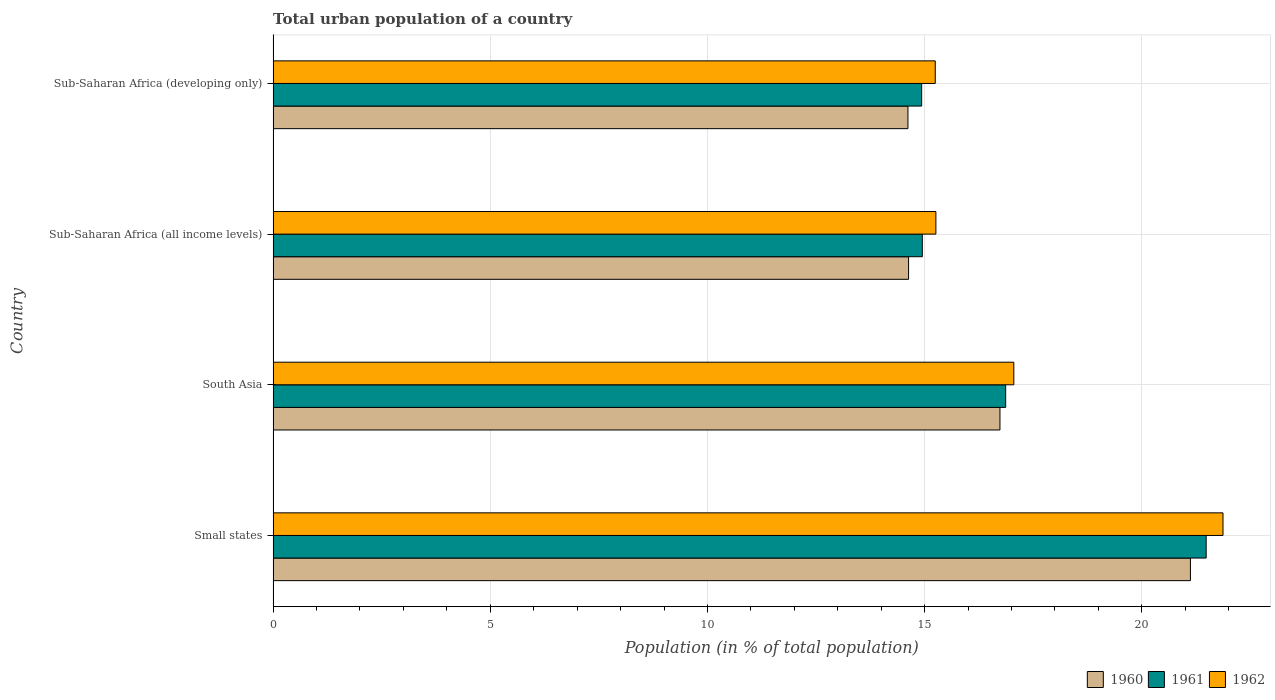How many groups of bars are there?
Offer a terse response. 4. Are the number of bars per tick equal to the number of legend labels?
Your response must be concise. Yes. Are the number of bars on each tick of the Y-axis equal?
Make the answer very short. Yes. How many bars are there on the 3rd tick from the bottom?
Provide a succinct answer. 3. What is the label of the 2nd group of bars from the top?
Offer a very short reply. Sub-Saharan Africa (all income levels). What is the urban population in 1962 in Small states?
Ensure brevity in your answer.  21.87. Across all countries, what is the maximum urban population in 1961?
Offer a very short reply. 21.48. Across all countries, what is the minimum urban population in 1962?
Give a very brief answer. 15.25. In which country was the urban population in 1962 maximum?
Your response must be concise. Small states. In which country was the urban population in 1962 minimum?
Offer a very short reply. Sub-Saharan Africa (developing only). What is the total urban population in 1962 in the graph?
Offer a terse response. 69.43. What is the difference between the urban population in 1960 in Small states and that in Sub-Saharan Africa (all income levels)?
Your answer should be very brief. 6.49. What is the difference between the urban population in 1961 in South Asia and the urban population in 1960 in Sub-Saharan Africa (all income levels)?
Provide a succinct answer. 2.24. What is the average urban population in 1960 per country?
Ensure brevity in your answer.  16.78. What is the difference between the urban population in 1960 and urban population in 1961 in Sub-Saharan Africa (developing only)?
Make the answer very short. -0.32. In how many countries, is the urban population in 1960 greater than 9 %?
Your response must be concise. 4. What is the ratio of the urban population in 1960 in Small states to that in Sub-Saharan Africa (developing only)?
Provide a succinct answer. 1.44. What is the difference between the highest and the second highest urban population in 1961?
Give a very brief answer. 4.62. What is the difference between the highest and the lowest urban population in 1962?
Your answer should be compact. 6.63. Is the sum of the urban population in 1961 in South Asia and Sub-Saharan Africa (developing only) greater than the maximum urban population in 1962 across all countries?
Offer a very short reply. Yes. What does the 2nd bar from the top in Small states represents?
Offer a terse response. 1961. What does the 1st bar from the bottom in Sub-Saharan Africa (all income levels) represents?
Ensure brevity in your answer.  1960. How many bars are there?
Offer a terse response. 12. Are all the bars in the graph horizontal?
Your response must be concise. Yes. What is the difference between two consecutive major ticks on the X-axis?
Provide a succinct answer. 5. Are the values on the major ticks of X-axis written in scientific E-notation?
Make the answer very short. No. Does the graph contain any zero values?
Give a very brief answer. No. Where does the legend appear in the graph?
Your answer should be compact. Bottom right. What is the title of the graph?
Offer a terse response. Total urban population of a country. Does "1976" appear as one of the legend labels in the graph?
Give a very brief answer. No. What is the label or title of the X-axis?
Your response must be concise. Population (in % of total population). What is the Population (in % of total population) of 1960 in Small states?
Provide a succinct answer. 21.12. What is the Population (in % of total population) of 1961 in Small states?
Ensure brevity in your answer.  21.48. What is the Population (in % of total population) of 1962 in Small states?
Offer a terse response. 21.87. What is the Population (in % of total population) of 1960 in South Asia?
Provide a short and direct response. 16.74. What is the Population (in % of total population) of 1961 in South Asia?
Provide a succinct answer. 16.87. What is the Population (in % of total population) in 1962 in South Asia?
Ensure brevity in your answer.  17.05. What is the Population (in % of total population) in 1960 in Sub-Saharan Africa (all income levels)?
Provide a short and direct response. 14.63. What is the Population (in % of total population) of 1961 in Sub-Saharan Africa (all income levels)?
Offer a terse response. 14.95. What is the Population (in % of total population) in 1962 in Sub-Saharan Africa (all income levels)?
Provide a short and direct response. 15.26. What is the Population (in % of total population) of 1960 in Sub-Saharan Africa (developing only)?
Give a very brief answer. 14.62. What is the Population (in % of total population) of 1961 in Sub-Saharan Africa (developing only)?
Offer a terse response. 14.93. What is the Population (in % of total population) in 1962 in Sub-Saharan Africa (developing only)?
Your response must be concise. 15.25. Across all countries, what is the maximum Population (in % of total population) in 1960?
Provide a short and direct response. 21.12. Across all countries, what is the maximum Population (in % of total population) of 1961?
Give a very brief answer. 21.48. Across all countries, what is the maximum Population (in % of total population) of 1962?
Give a very brief answer. 21.87. Across all countries, what is the minimum Population (in % of total population) in 1960?
Keep it short and to the point. 14.62. Across all countries, what is the minimum Population (in % of total population) in 1961?
Your response must be concise. 14.93. Across all countries, what is the minimum Population (in % of total population) of 1962?
Give a very brief answer. 15.25. What is the total Population (in % of total population) in 1960 in the graph?
Offer a very short reply. 67.1. What is the total Population (in % of total population) of 1961 in the graph?
Provide a short and direct response. 68.23. What is the total Population (in % of total population) in 1962 in the graph?
Your answer should be compact. 69.43. What is the difference between the Population (in % of total population) of 1960 in Small states and that in South Asia?
Make the answer very short. 4.38. What is the difference between the Population (in % of total population) in 1961 in Small states and that in South Asia?
Make the answer very short. 4.62. What is the difference between the Population (in % of total population) of 1962 in Small states and that in South Asia?
Give a very brief answer. 4.82. What is the difference between the Population (in % of total population) of 1960 in Small states and that in Sub-Saharan Africa (all income levels)?
Give a very brief answer. 6.49. What is the difference between the Population (in % of total population) in 1961 in Small states and that in Sub-Saharan Africa (all income levels)?
Keep it short and to the point. 6.54. What is the difference between the Population (in % of total population) of 1962 in Small states and that in Sub-Saharan Africa (all income levels)?
Make the answer very short. 6.61. What is the difference between the Population (in % of total population) in 1960 in Small states and that in Sub-Saharan Africa (developing only)?
Your answer should be very brief. 6.5. What is the difference between the Population (in % of total population) in 1961 in Small states and that in Sub-Saharan Africa (developing only)?
Your response must be concise. 6.55. What is the difference between the Population (in % of total population) in 1962 in Small states and that in Sub-Saharan Africa (developing only)?
Your answer should be compact. 6.63. What is the difference between the Population (in % of total population) in 1960 in South Asia and that in Sub-Saharan Africa (all income levels)?
Make the answer very short. 2.1. What is the difference between the Population (in % of total population) in 1961 in South Asia and that in Sub-Saharan Africa (all income levels)?
Your response must be concise. 1.92. What is the difference between the Population (in % of total population) of 1962 in South Asia and that in Sub-Saharan Africa (all income levels)?
Your answer should be very brief. 1.79. What is the difference between the Population (in % of total population) in 1960 in South Asia and that in Sub-Saharan Africa (developing only)?
Offer a very short reply. 2.12. What is the difference between the Population (in % of total population) of 1961 in South Asia and that in Sub-Saharan Africa (developing only)?
Keep it short and to the point. 1.93. What is the difference between the Population (in % of total population) of 1962 in South Asia and that in Sub-Saharan Africa (developing only)?
Make the answer very short. 1.81. What is the difference between the Population (in % of total population) of 1960 in Sub-Saharan Africa (all income levels) and that in Sub-Saharan Africa (developing only)?
Ensure brevity in your answer.  0.01. What is the difference between the Population (in % of total population) of 1961 in Sub-Saharan Africa (all income levels) and that in Sub-Saharan Africa (developing only)?
Provide a succinct answer. 0.01. What is the difference between the Population (in % of total population) of 1962 in Sub-Saharan Africa (all income levels) and that in Sub-Saharan Africa (developing only)?
Ensure brevity in your answer.  0.01. What is the difference between the Population (in % of total population) of 1960 in Small states and the Population (in % of total population) of 1961 in South Asia?
Provide a succinct answer. 4.25. What is the difference between the Population (in % of total population) of 1960 in Small states and the Population (in % of total population) of 1962 in South Asia?
Provide a short and direct response. 4.07. What is the difference between the Population (in % of total population) of 1961 in Small states and the Population (in % of total population) of 1962 in South Asia?
Keep it short and to the point. 4.43. What is the difference between the Population (in % of total population) of 1960 in Small states and the Population (in % of total population) of 1961 in Sub-Saharan Africa (all income levels)?
Keep it short and to the point. 6.17. What is the difference between the Population (in % of total population) of 1960 in Small states and the Population (in % of total population) of 1962 in Sub-Saharan Africa (all income levels)?
Provide a short and direct response. 5.86. What is the difference between the Population (in % of total population) in 1961 in Small states and the Population (in % of total population) in 1962 in Sub-Saharan Africa (all income levels)?
Ensure brevity in your answer.  6.22. What is the difference between the Population (in % of total population) in 1960 in Small states and the Population (in % of total population) in 1961 in Sub-Saharan Africa (developing only)?
Offer a terse response. 6.19. What is the difference between the Population (in % of total population) in 1960 in Small states and the Population (in % of total population) in 1962 in Sub-Saharan Africa (developing only)?
Your response must be concise. 5.87. What is the difference between the Population (in % of total population) in 1961 in Small states and the Population (in % of total population) in 1962 in Sub-Saharan Africa (developing only)?
Your answer should be very brief. 6.24. What is the difference between the Population (in % of total population) of 1960 in South Asia and the Population (in % of total population) of 1961 in Sub-Saharan Africa (all income levels)?
Make the answer very short. 1.79. What is the difference between the Population (in % of total population) in 1960 in South Asia and the Population (in % of total population) in 1962 in Sub-Saharan Africa (all income levels)?
Your answer should be compact. 1.48. What is the difference between the Population (in % of total population) of 1961 in South Asia and the Population (in % of total population) of 1962 in Sub-Saharan Africa (all income levels)?
Ensure brevity in your answer.  1.61. What is the difference between the Population (in % of total population) of 1960 in South Asia and the Population (in % of total population) of 1961 in Sub-Saharan Africa (developing only)?
Your answer should be very brief. 1.8. What is the difference between the Population (in % of total population) of 1960 in South Asia and the Population (in % of total population) of 1962 in Sub-Saharan Africa (developing only)?
Your response must be concise. 1.49. What is the difference between the Population (in % of total population) of 1961 in South Asia and the Population (in % of total population) of 1962 in Sub-Saharan Africa (developing only)?
Make the answer very short. 1.62. What is the difference between the Population (in % of total population) of 1960 in Sub-Saharan Africa (all income levels) and the Population (in % of total population) of 1961 in Sub-Saharan Africa (developing only)?
Ensure brevity in your answer.  -0.3. What is the difference between the Population (in % of total population) of 1960 in Sub-Saharan Africa (all income levels) and the Population (in % of total population) of 1962 in Sub-Saharan Africa (developing only)?
Ensure brevity in your answer.  -0.61. What is the difference between the Population (in % of total population) in 1961 in Sub-Saharan Africa (all income levels) and the Population (in % of total population) in 1962 in Sub-Saharan Africa (developing only)?
Your response must be concise. -0.3. What is the average Population (in % of total population) of 1960 per country?
Your answer should be very brief. 16.78. What is the average Population (in % of total population) of 1961 per country?
Give a very brief answer. 17.06. What is the average Population (in % of total population) of 1962 per country?
Ensure brevity in your answer.  17.36. What is the difference between the Population (in % of total population) of 1960 and Population (in % of total population) of 1961 in Small states?
Your answer should be compact. -0.36. What is the difference between the Population (in % of total population) of 1960 and Population (in % of total population) of 1962 in Small states?
Make the answer very short. -0.75. What is the difference between the Population (in % of total population) in 1961 and Population (in % of total population) in 1962 in Small states?
Offer a terse response. -0.39. What is the difference between the Population (in % of total population) in 1960 and Population (in % of total population) in 1961 in South Asia?
Provide a succinct answer. -0.13. What is the difference between the Population (in % of total population) of 1960 and Population (in % of total population) of 1962 in South Asia?
Your answer should be very brief. -0.32. What is the difference between the Population (in % of total population) of 1961 and Population (in % of total population) of 1962 in South Asia?
Offer a terse response. -0.19. What is the difference between the Population (in % of total population) in 1960 and Population (in % of total population) in 1961 in Sub-Saharan Africa (all income levels)?
Your response must be concise. -0.32. What is the difference between the Population (in % of total population) in 1960 and Population (in % of total population) in 1962 in Sub-Saharan Africa (all income levels)?
Provide a short and direct response. -0.63. What is the difference between the Population (in % of total population) of 1961 and Population (in % of total population) of 1962 in Sub-Saharan Africa (all income levels)?
Your answer should be compact. -0.31. What is the difference between the Population (in % of total population) in 1960 and Population (in % of total population) in 1961 in Sub-Saharan Africa (developing only)?
Offer a very short reply. -0.32. What is the difference between the Population (in % of total population) in 1960 and Population (in % of total population) in 1962 in Sub-Saharan Africa (developing only)?
Offer a very short reply. -0.63. What is the difference between the Population (in % of total population) in 1961 and Population (in % of total population) in 1962 in Sub-Saharan Africa (developing only)?
Keep it short and to the point. -0.31. What is the ratio of the Population (in % of total population) of 1960 in Small states to that in South Asia?
Keep it short and to the point. 1.26. What is the ratio of the Population (in % of total population) in 1961 in Small states to that in South Asia?
Your response must be concise. 1.27. What is the ratio of the Population (in % of total population) in 1962 in Small states to that in South Asia?
Offer a terse response. 1.28. What is the ratio of the Population (in % of total population) in 1960 in Small states to that in Sub-Saharan Africa (all income levels)?
Keep it short and to the point. 1.44. What is the ratio of the Population (in % of total population) of 1961 in Small states to that in Sub-Saharan Africa (all income levels)?
Offer a terse response. 1.44. What is the ratio of the Population (in % of total population) of 1962 in Small states to that in Sub-Saharan Africa (all income levels)?
Provide a short and direct response. 1.43. What is the ratio of the Population (in % of total population) of 1960 in Small states to that in Sub-Saharan Africa (developing only)?
Offer a terse response. 1.44. What is the ratio of the Population (in % of total population) of 1961 in Small states to that in Sub-Saharan Africa (developing only)?
Ensure brevity in your answer.  1.44. What is the ratio of the Population (in % of total population) of 1962 in Small states to that in Sub-Saharan Africa (developing only)?
Your answer should be compact. 1.43. What is the ratio of the Population (in % of total population) in 1960 in South Asia to that in Sub-Saharan Africa (all income levels)?
Offer a very short reply. 1.14. What is the ratio of the Population (in % of total population) of 1961 in South Asia to that in Sub-Saharan Africa (all income levels)?
Offer a terse response. 1.13. What is the ratio of the Population (in % of total population) in 1962 in South Asia to that in Sub-Saharan Africa (all income levels)?
Provide a short and direct response. 1.12. What is the ratio of the Population (in % of total population) in 1960 in South Asia to that in Sub-Saharan Africa (developing only)?
Offer a very short reply. 1.14. What is the ratio of the Population (in % of total population) of 1961 in South Asia to that in Sub-Saharan Africa (developing only)?
Provide a short and direct response. 1.13. What is the ratio of the Population (in % of total population) in 1962 in South Asia to that in Sub-Saharan Africa (developing only)?
Make the answer very short. 1.12. What is the ratio of the Population (in % of total population) of 1961 in Sub-Saharan Africa (all income levels) to that in Sub-Saharan Africa (developing only)?
Make the answer very short. 1. What is the difference between the highest and the second highest Population (in % of total population) in 1960?
Make the answer very short. 4.38. What is the difference between the highest and the second highest Population (in % of total population) in 1961?
Provide a short and direct response. 4.62. What is the difference between the highest and the second highest Population (in % of total population) of 1962?
Give a very brief answer. 4.82. What is the difference between the highest and the lowest Population (in % of total population) in 1960?
Offer a very short reply. 6.5. What is the difference between the highest and the lowest Population (in % of total population) of 1961?
Your response must be concise. 6.55. What is the difference between the highest and the lowest Population (in % of total population) in 1962?
Offer a terse response. 6.63. 